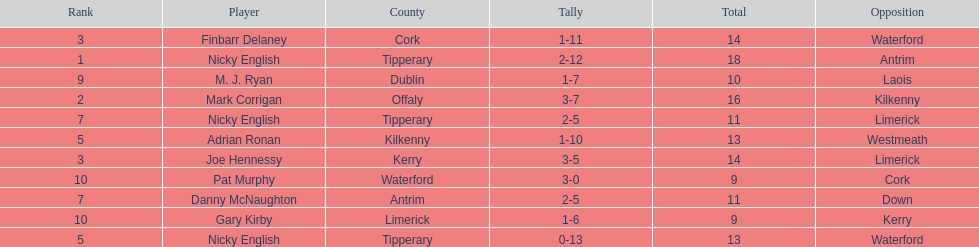How many people are on the list? 9. 